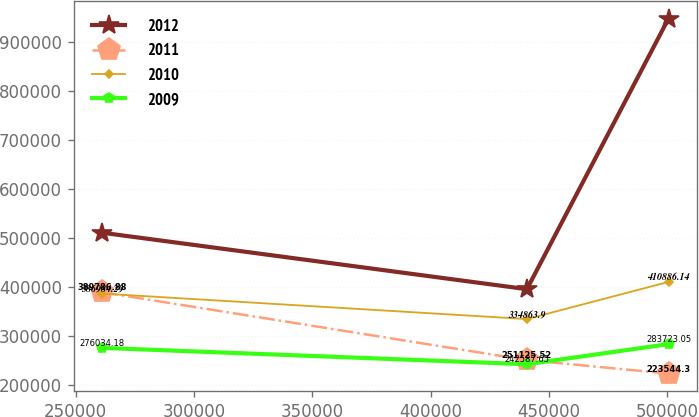<chart> <loc_0><loc_0><loc_500><loc_500><line_chart><ecel><fcel>2012<fcel>2011<fcel>2010<fcel>2009<nl><fcel>261139<fcel>511358<fcel>389787<fcel>386984<fcel>276034<nl><fcel>440635<fcel>395967<fcel>251126<fcel>334864<fcel>242588<nl><fcel>500465<fcel>949002<fcel>223544<fcel>410886<fcel>283723<nl></chart> 